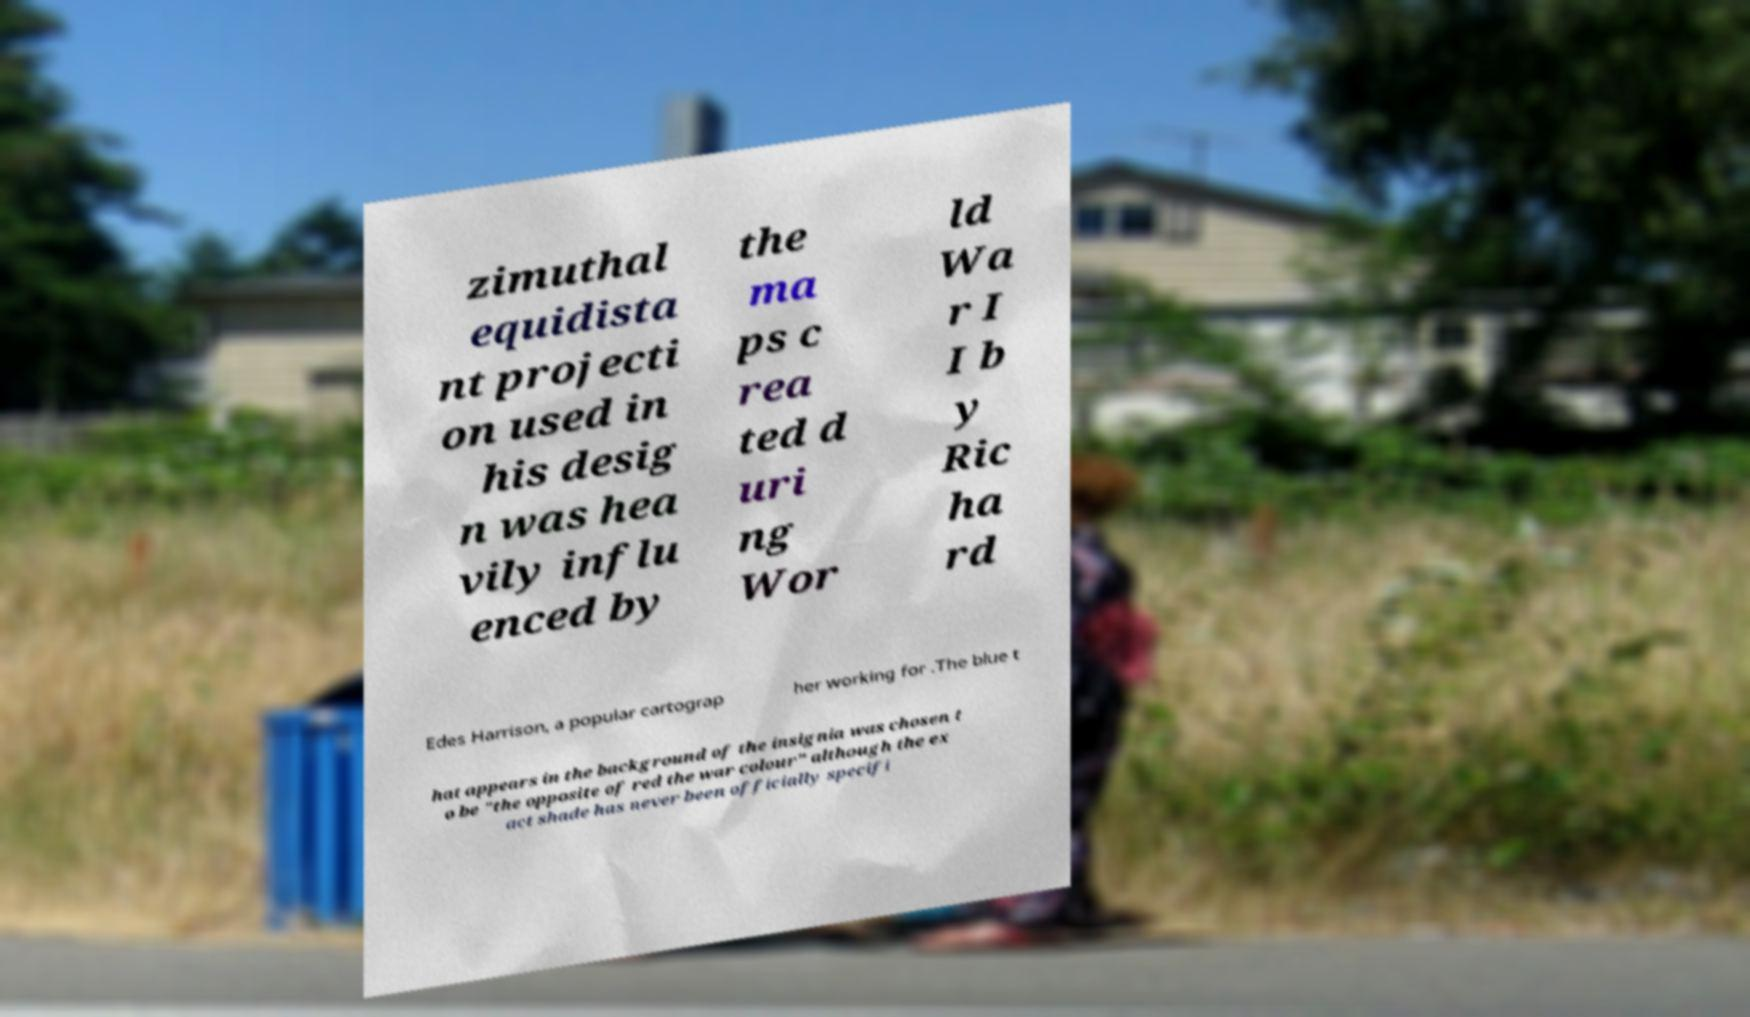Please identify and transcribe the text found in this image. zimuthal equidista nt projecti on used in his desig n was hea vily influ enced by the ma ps c rea ted d uri ng Wor ld Wa r I I b y Ric ha rd Edes Harrison, a popular cartograp her working for .The blue t hat appears in the background of the insignia was chosen t o be "the opposite of red the war colour" although the ex act shade has never been officially specifi 